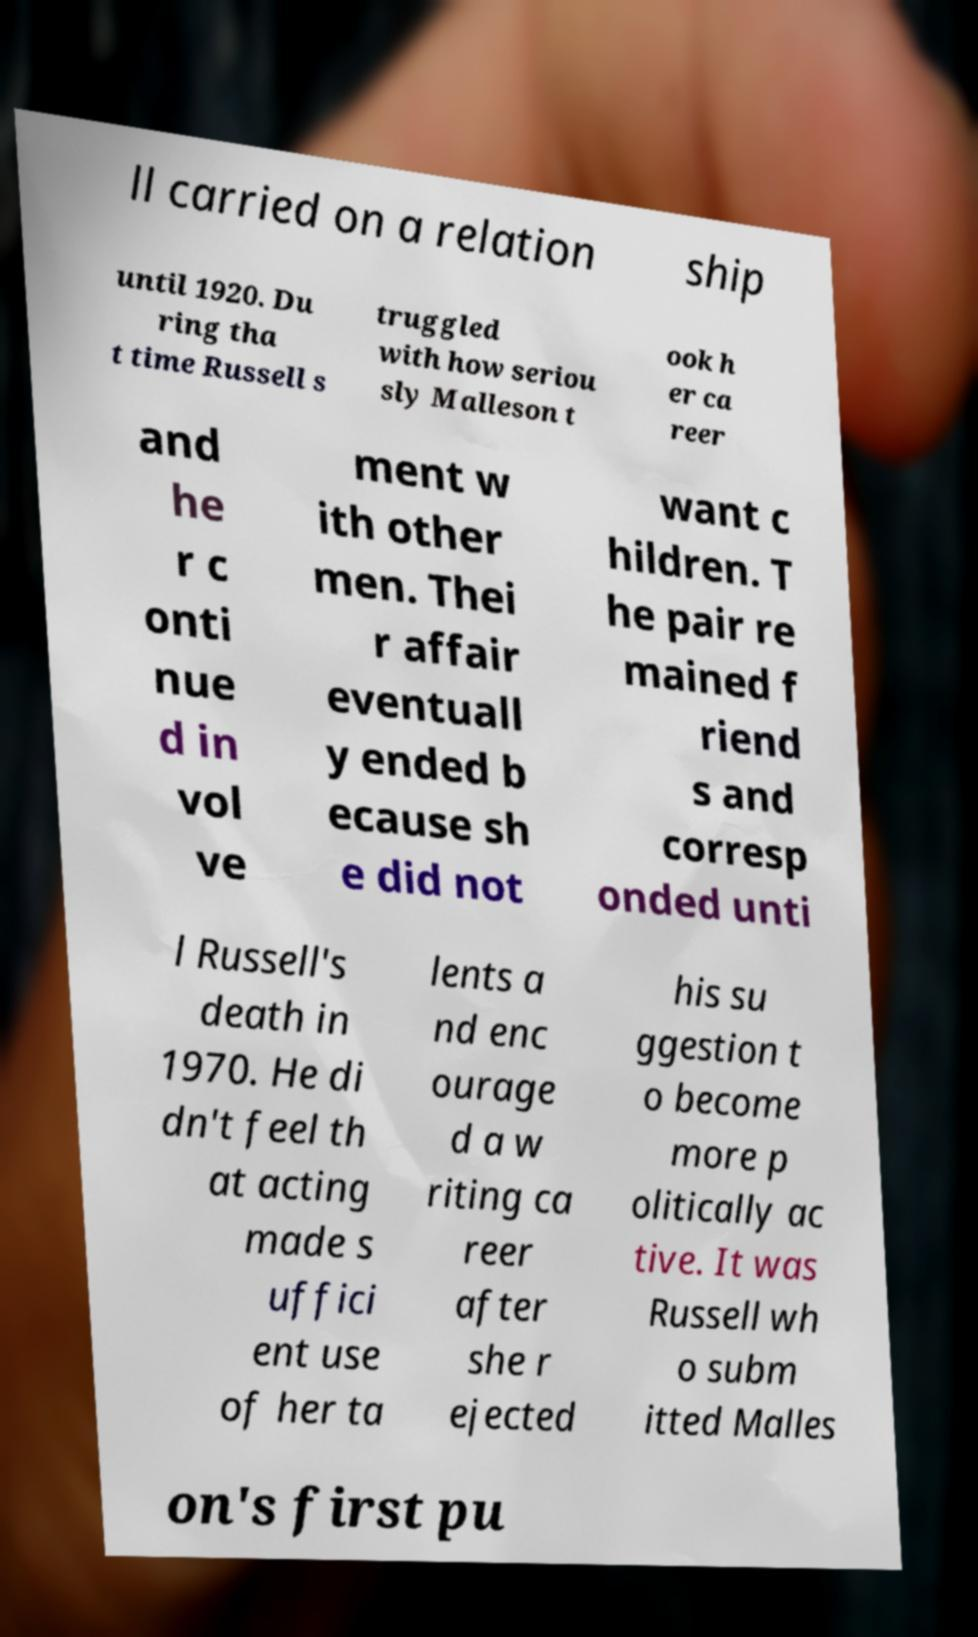There's text embedded in this image that I need extracted. Can you transcribe it verbatim? ll carried on a relation ship until 1920. Du ring tha t time Russell s truggled with how seriou sly Malleson t ook h er ca reer and he r c onti nue d in vol ve ment w ith other men. Thei r affair eventuall y ended b ecause sh e did not want c hildren. T he pair re mained f riend s and corresp onded unti l Russell's death in 1970. He di dn't feel th at acting made s uffici ent use of her ta lents a nd enc ourage d a w riting ca reer after she r ejected his su ggestion t o become more p olitically ac tive. It was Russell wh o subm itted Malles on's first pu 